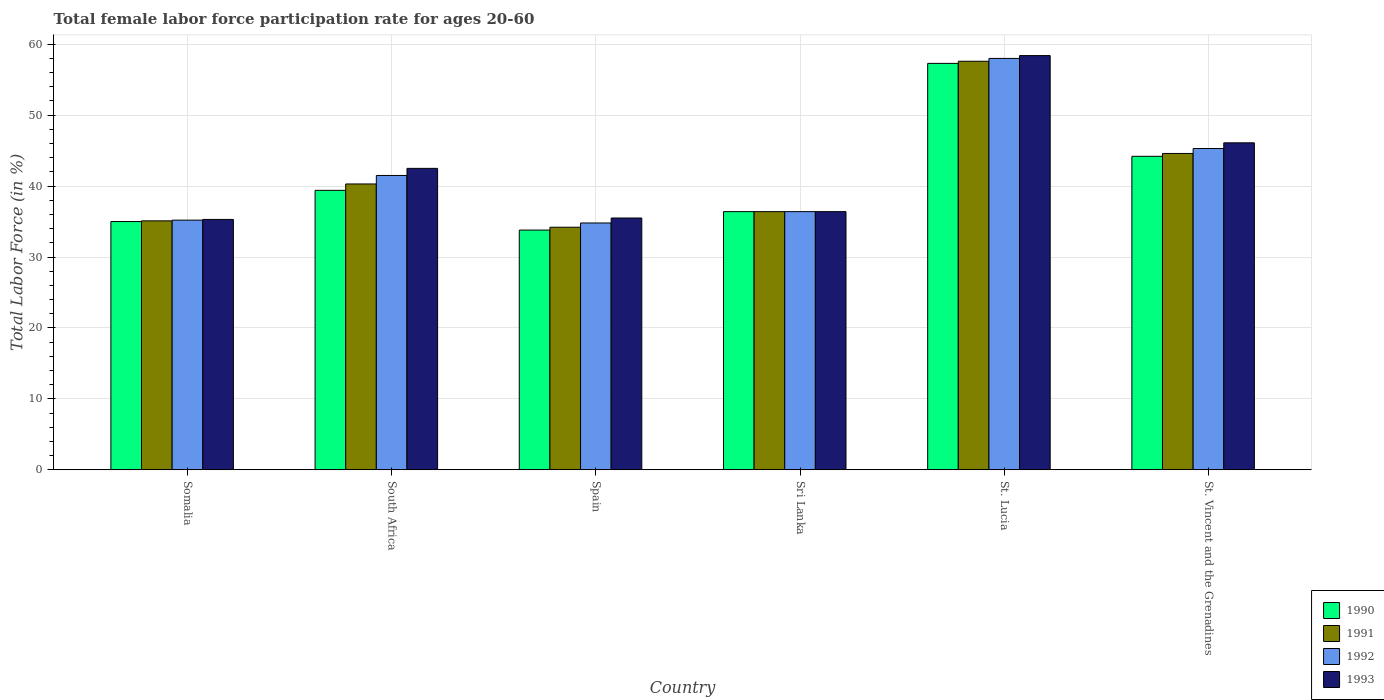How many different coloured bars are there?
Your answer should be very brief. 4. How many bars are there on the 2nd tick from the right?
Your response must be concise. 4. What is the label of the 5th group of bars from the left?
Your answer should be very brief. St. Lucia. What is the female labor force participation rate in 1992 in Somalia?
Offer a terse response. 35.2. Across all countries, what is the maximum female labor force participation rate in 1991?
Your response must be concise. 57.6. Across all countries, what is the minimum female labor force participation rate in 1990?
Your response must be concise. 33.8. In which country was the female labor force participation rate in 1990 maximum?
Your answer should be compact. St. Lucia. What is the total female labor force participation rate in 1993 in the graph?
Your response must be concise. 254.2. What is the difference between the female labor force participation rate in 1990 in South Africa and the female labor force participation rate in 1992 in Spain?
Provide a succinct answer. 4.6. What is the average female labor force participation rate in 1990 per country?
Offer a terse response. 41.02. What is the difference between the female labor force participation rate of/in 1991 and female labor force participation rate of/in 1990 in Somalia?
Make the answer very short. 0.1. In how many countries, is the female labor force participation rate in 1991 greater than 20 %?
Your answer should be very brief. 6. What is the ratio of the female labor force participation rate in 1990 in South Africa to that in St. Lucia?
Give a very brief answer. 0.69. Is the female labor force participation rate in 1990 in South Africa less than that in Spain?
Offer a very short reply. No. What is the difference between the highest and the second highest female labor force participation rate in 1992?
Give a very brief answer. -16.5. What is the difference between the highest and the lowest female labor force participation rate in 1992?
Provide a short and direct response. 23.2. Is it the case that in every country, the sum of the female labor force participation rate in 1993 and female labor force participation rate in 1992 is greater than the sum of female labor force participation rate in 1991 and female labor force participation rate in 1990?
Give a very brief answer. No. What does the 4th bar from the left in South Africa represents?
Offer a terse response. 1993. Is it the case that in every country, the sum of the female labor force participation rate in 1993 and female labor force participation rate in 1992 is greater than the female labor force participation rate in 1991?
Keep it short and to the point. Yes. How many bars are there?
Offer a very short reply. 24. Are all the bars in the graph horizontal?
Offer a terse response. No. Does the graph contain grids?
Your answer should be very brief. Yes. What is the title of the graph?
Provide a succinct answer. Total female labor force participation rate for ages 20-60. Does "1993" appear as one of the legend labels in the graph?
Your answer should be very brief. Yes. What is the label or title of the Y-axis?
Make the answer very short. Total Labor Force (in %). What is the Total Labor Force (in %) in 1991 in Somalia?
Give a very brief answer. 35.1. What is the Total Labor Force (in %) of 1992 in Somalia?
Give a very brief answer. 35.2. What is the Total Labor Force (in %) in 1993 in Somalia?
Ensure brevity in your answer.  35.3. What is the Total Labor Force (in %) of 1990 in South Africa?
Your answer should be compact. 39.4. What is the Total Labor Force (in %) in 1991 in South Africa?
Make the answer very short. 40.3. What is the Total Labor Force (in %) in 1992 in South Africa?
Your answer should be compact. 41.5. What is the Total Labor Force (in %) of 1993 in South Africa?
Give a very brief answer. 42.5. What is the Total Labor Force (in %) of 1990 in Spain?
Provide a succinct answer. 33.8. What is the Total Labor Force (in %) of 1991 in Spain?
Offer a very short reply. 34.2. What is the Total Labor Force (in %) in 1992 in Spain?
Provide a short and direct response. 34.8. What is the Total Labor Force (in %) of 1993 in Spain?
Your answer should be very brief. 35.5. What is the Total Labor Force (in %) of 1990 in Sri Lanka?
Offer a terse response. 36.4. What is the Total Labor Force (in %) in 1991 in Sri Lanka?
Provide a succinct answer. 36.4. What is the Total Labor Force (in %) of 1992 in Sri Lanka?
Offer a very short reply. 36.4. What is the Total Labor Force (in %) in 1993 in Sri Lanka?
Offer a terse response. 36.4. What is the Total Labor Force (in %) of 1990 in St. Lucia?
Provide a short and direct response. 57.3. What is the Total Labor Force (in %) in 1991 in St. Lucia?
Provide a short and direct response. 57.6. What is the Total Labor Force (in %) of 1993 in St. Lucia?
Offer a terse response. 58.4. What is the Total Labor Force (in %) in 1990 in St. Vincent and the Grenadines?
Provide a short and direct response. 44.2. What is the Total Labor Force (in %) of 1991 in St. Vincent and the Grenadines?
Keep it short and to the point. 44.6. What is the Total Labor Force (in %) of 1992 in St. Vincent and the Grenadines?
Offer a very short reply. 45.3. What is the Total Labor Force (in %) of 1993 in St. Vincent and the Grenadines?
Your response must be concise. 46.1. Across all countries, what is the maximum Total Labor Force (in %) of 1990?
Give a very brief answer. 57.3. Across all countries, what is the maximum Total Labor Force (in %) in 1991?
Your answer should be compact. 57.6. Across all countries, what is the maximum Total Labor Force (in %) in 1993?
Provide a succinct answer. 58.4. Across all countries, what is the minimum Total Labor Force (in %) in 1990?
Give a very brief answer. 33.8. Across all countries, what is the minimum Total Labor Force (in %) of 1991?
Your answer should be compact. 34.2. Across all countries, what is the minimum Total Labor Force (in %) of 1992?
Ensure brevity in your answer.  34.8. Across all countries, what is the minimum Total Labor Force (in %) in 1993?
Your response must be concise. 35.3. What is the total Total Labor Force (in %) of 1990 in the graph?
Your answer should be compact. 246.1. What is the total Total Labor Force (in %) of 1991 in the graph?
Offer a very short reply. 248.2. What is the total Total Labor Force (in %) of 1992 in the graph?
Your response must be concise. 251.2. What is the total Total Labor Force (in %) in 1993 in the graph?
Your answer should be very brief. 254.2. What is the difference between the Total Labor Force (in %) of 1990 in Somalia and that in Spain?
Provide a short and direct response. 1.2. What is the difference between the Total Labor Force (in %) of 1990 in Somalia and that in Sri Lanka?
Your answer should be compact. -1.4. What is the difference between the Total Labor Force (in %) of 1990 in Somalia and that in St. Lucia?
Your response must be concise. -22.3. What is the difference between the Total Labor Force (in %) of 1991 in Somalia and that in St. Lucia?
Keep it short and to the point. -22.5. What is the difference between the Total Labor Force (in %) of 1992 in Somalia and that in St. Lucia?
Your answer should be very brief. -22.8. What is the difference between the Total Labor Force (in %) of 1993 in Somalia and that in St. Lucia?
Offer a very short reply. -23.1. What is the difference between the Total Labor Force (in %) of 1991 in Somalia and that in St. Vincent and the Grenadines?
Make the answer very short. -9.5. What is the difference between the Total Labor Force (in %) of 1992 in Somalia and that in St. Vincent and the Grenadines?
Your answer should be compact. -10.1. What is the difference between the Total Labor Force (in %) in 1993 in Somalia and that in St. Vincent and the Grenadines?
Make the answer very short. -10.8. What is the difference between the Total Labor Force (in %) in 1992 in South Africa and that in Spain?
Provide a succinct answer. 6.7. What is the difference between the Total Labor Force (in %) in 1993 in South Africa and that in Spain?
Provide a short and direct response. 7. What is the difference between the Total Labor Force (in %) of 1993 in South Africa and that in Sri Lanka?
Give a very brief answer. 6.1. What is the difference between the Total Labor Force (in %) in 1990 in South Africa and that in St. Lucia?
Provide a succinct answer. -17.9. What is the difference between the Total Labor Force (in %) in 1991 in South Africa and that in St. Lucia?
Ensure brevity in your answer.  -17.3. What is the difference between the Total Labor Force (in %) in 1992 in South Africa and that in St. Lucia?
Provide a short and direct response. -16.5. What is the difference between the Total Labor Force (in %) in 1993 in South Africa and that in St. Lucia?
Your answer should be compact. -15.9. What is the difference between the Total Labor Force (in %) in 1992 in South Africa and that in St. Vincent and the Grenadines?
Offer a terse response. -3.8. What is the difference between the Total Labor Force (in %) in 1993 in South Africa and that in St. Vincent and the Grenadines?
Ensure brevity in your answer.  -3.6. What is the difference between the Total Labor Force (in %) of 1990 in Spain and that in Sri Lanka?
Offer a very short reply. -2.6. What is the difference between the Total Labor Force (in %) of 1991 in Spain and that in Sri Lanka?
Your answer should be very brief. -2.2. What is the difference between the Total Labor Force (in %) of 1990 in Spain and that in St. Lucia?
Provide a succinct answer. -23.5. What is the difference between the Total Labor Force (in %) in 1991 in Spain and that in St. Lucia?
Offer a very short reply. -23.4. What is the difference between the Total Labor Force (in %) of 1992 in Spain and that in St. Lucia?
Provide a short and direct response. -23.2. What is the difference between the Total Labor Force (in %) in 1993 in Spain and that in St. Lucia?
Offer a terse response. -22.9. What is the difference between the Total Labor Force (in %) of 1990 in Spain and that in St. Vincent and the Grenadines?
Your answer should be very brief. -10.4. What is the difference between the Total Labor Force (in %) in 1991 in Spain and that in St. Vincent and the Grenadines?
Provide a short and direct response. -10.4. What is the difference between the Total Labor Force (in %) of 1990 in Sri Lanka and that in St. Lucia?
Your answer should be very brief. -20.9. What is the difference between the Total Labor Force (in %) of 1991 in Sri Lanka and that in St. Lucia?
Offer a very short reply. -21.2. What is the difference between the Total Labor Force (in %) of 1992 in Sri Lanka and that in St. Lucia?
Your response must be concise. -21.6. What is the difference between the Total Labor Force (in %) in 1993 in Sri Lanka and that in St. Lucia?
Ensure brevity in your answer.  -22. What is the difference between the Total Labor Force (in %) in 1990 in Sri Lanka and that in St. Vincent and the Grenadines?
Give a very brief answer. -7.8. What is the difference between the Total Labor Force (in %) of 1992 in Sri Lanka and that in St. Vincent and the Grenadines?
Your response must be concise. -8.9. What is the difference between the Total Labor Force (in %) in 1993 in Sri Lanka and that in St. Vincent and the Grenadines?
Offer a very short reply. -9.7. What is the difference between the Total Labor Force (in %) of 1990 in St. Lucia and that in St. Vincent and the Grenadines?
Offer a very short reply. 13.1. What is the difference between the Total Labor Force (in %) of 1990 in Somalia and the Total Labor Force (in %) of 1992 in South Africa?
Your response must be concise. -6.5. What is the difference between the Total Labor Force (in %) in 1991 in Somalia and the Total Labor Force (in %) in 1992 in South Africa?
Offer a terse response. -6.4. What is the difference between the Total Labor Force (in %) of 1991 in Somalia and the Total Labor Force (in %) of 1993 in South Africa?
Provide a short and direct response. -7.4. What is the difference between the Total Labor Force (in %) in 1990 in Somalia and the Total Labor Force (in %) in 1993 in Spain?
Provide a succinct answer. -0.5. What is the difference between the Total Labor Force (in %) of 1991 in Somalia and the Total Labor Force (in %) of 1992 in Spain?
Provide a succinct answer. 0.3. What is the difference between the Total Labor Force (in %) in 1992 in Somalia and the Total Labor Force (in %) in 1993 in Spain?
Offer a very short reply. -0.3. What is the difference between the Total Labor Force (in %) of 1990 in Somalia and the Total Labor Force (in %) of 1992 in Sri Lanka?
Give a very brief answer. -1.4. What is the difference between the Total Labor Force (in %) in 1990 in Somalia and the Total Labor Force (in %) in 1993 in Sri Lanka?
Your answer should be very brief. -1.4. What is the difference between the Total Labor Force (in %) of 1991 in Somalia and the Total Labor Force (in %) of 1992 in Sri Lanka?
Your answer should be very brief. -1.3. What is the difference between the Total Labor Force (in %) in 1990 in Somalia and the Total Labor Force (in %) in 1991 in St. Lucia?
Offer a terse response. -22.6. What is the difference between the Total Labor Force (in %) in 1990 in Somalia and the Total Labor Force (in %) in 1992 in St. Lucia?
Offer a very short reply. -23. What is the difference between the Total Labor Force (in %) of 1990 in Somalia and the Total Labor Force (in %) of 1993 in St. Lucia?
Offer a terse response. -23.4. What is the difference between the Total Labor Force (in %) of 1991 in Somalia and the Total Labor Force (in %) of 1992 in St. Lucia?
Offer a very short reply. -22.9. What is the difference between the Total Labor Force (in %) in 1991 in Somalia and the Total Labor Force (in %) in 1993 in St. Lucia?
Your answer should be compact. -23.3. What is the difference between the Total Labor Force (in %) in 1992 in Somalia and the Total Labor Force (in %) in 1993 in St. Lucia?
Provide a short and direct response. -23.2. What is the difference between the Total Labor Force (in %) in 1990 in Somalia and the Total Labor Force (in %) in 1992 in St. Vincent and the Grenadines?
Provide a succinct answer. -10.3. What is the difference between the Total Labor Force (in %) of 1991 in Somalia and the Total Labor Force (in %) of 1992 in St. Vincent and the Grenadines?
Your answer should be compact. -10.2. What is the difference between the Total Labor Force (in %) of 1991 in Somalia and the Total Labor Force (in %) of 1993 in St. Vincent and the Grenadines?
Ensure brevity in your answer.  -11. What is the difference between the Total Labor Force (in %) of 1992 in Somalia and the Total Labor Force (in %) of 1993 in St. Vincent and the Grenadines?
Provide a short and direct response. -10.9. What is the difference between the Total Labor Force (in %) in 1990 in South Africa and the Total Labor Force (in %) in 1992 in Spain?
Your answer should be very brief. 4.6. What is the difference between the Total Labor Force (in %) in 1991 in South Africa and the Total Labor Force (in %) in 1992 in Spain?
Your response must be concise. 5.5. What is the difference between the Total Labor Force (in %) of 1990 in South Africa and the Total Labor Force (in %) of 1992 in Sri Lanka?
Your response must be concise. 3. What is the difference between the Total Labor Force (in %) of 1991 in South Africa and the Total Labor Force (in %) of 1993 in Sri Lanka?
Ensure brevity in your answer.  3.9. What is the difference between the Total Labor Force (in %) in 1990 in South Africa and the Total Labor Force (in %) in 1991 in St. Lucia?
Your response must be concise. -18.2. What is the difference between the Total Labor Force (in %) of 1990 in South Africa and the Total Labor Force (in %) of 1992 in St. Lucia?
Make the answer very short. -18.6. What is the difference between the Total Labor Force (in %) in 1990 in South Africa and the Total Labor Force (in %) in 1993 in St. Lucia?
Make the answer very short. -19. What is the difference between the Total Labor Force (in %) in 1991 in South Africa and the Total Labor Force (in %) in 1992 in St. Lucia?
Ensure brevity in your answer.  -17.7. What is the difference between the Total Labor Force (in %) of 1991 in South Africa and the Total Labor Force (in %) of 1993 in St. Lucia?
Make the answer very short. -18.1. What is the difference between the Total Labor Force (in %) in 1992 in South Africa and the Total Labor Force (in %) in 1993 in St. Lucia?
Provide a succinct answer. -16.9. What is the difference between the Total Labor Force (in %) of 1991 in South Africa and the Total Labor Force (in %) of 1992 in St. Vincent and the Grenadines?
Ensure brevity in your answer.  -5. What is the difference between the Total Labor Force (in %) of 1992 in South Africa and the Total Labor Force (in %) of 1993 in St. Vincent and the Grenadines?
Provide a succinct answer. -4.6. What is the difference between the Total Labor Force (in %) in 1990 in Spain and the Total Labor Force (in %) in 1992 in Sri Lanka?
Provide a short and direct response. -2.6. What is the difference between the Total Labor Force (in %) in 1991 in Spain and the Total Labor Force (in %) in 1992 in Sri Lanka?
Offer a very short reply. -2.2. What is the difference between the Total Labor Force (in %) of 1992 in Spain and the Total Labor Force (in %) of 1993 in Sri Lanka?
Give a very brief answer. -1.6. What is the difference between the Total Labor Force (in %) of 1990 in Spain and the Total Labor Force (in %) of 1991 in St. Lucia?
Your response must be concise. -23.8. What is the difference between the Total Labor Force (in %) of 1990 in Spain and the Total Labor Force (in %) of 1992 in St. Lucia?
Keep it short and to the point. -24.2. What is the difference between the Total Labor Force (in %) in 1990 in Spain and the Total Labor Force (in %) in 1993 in St. Lucia?
Ensure brevity in your answer.  -24.6. What is the difference between the Total Labor Force (in %) of 1991 in Spain and the Total Labor Force (in %) of 1992 in St. Lucia?
Your answer should be very brief. -23.8. What is the difference between the Total Labor Force (in %) of 1991 in Spain and the Total Labor Force (in %) of 1993 in St. Lucia?
Give a very brief answer. -24.2. What is the difference between the Total Labor Force (in %) of 1992 in Spain and the Total Labor Force (in %) of 1993 in St. Lucia?
Your answer should be very brief. -23.6. What is the difference between the Total Labor Force (in %) in 1990 in Spain and the Total Labor Force (in %) in 1991 in St. Vincent and the Grenadines?
Your answer should be compact. -10.8. What is the difference between the Total Labor Force (in %) in 1991 in Spain and the Total Labor Force (in %) in 1992 in St. Vincent and the Grenadines?
Give a very brief answer. -11.1. What is the difference between the Total Labor Force (in %) of 1991 in Spain and the Total Labor Force (in %) of 1993 in St. Vincent and the Grenadines?
Give a very brief answer. -11.9. What is the difference between the Total Labor Force (in %) of 1992 in Spain and the Total Labor Force (in %) of 1993 in St. Vincent and the Grenadines?
Offer a very short reply. -11.3. What is the difference between the Total Labor Force (in %) of 1990 in Sri Lanka and the Total Labor Force (in %) of 1991 in St. Lucia?
Offer a very short reply. -21.2. What is the difference between the Total Labor Force (in %) in 1990 in Sri Lanka and the Total Labor Force (in %) in 1992 in St. Lucia?
Make the answer very short. -21.6. What is the difference between the Total Labor Force (in %) of 1990 in Sri Lanka and the Total Labor Force (in %) of 1993 in St. Lucia?
Offer a very short reply. -22. What is the difference between the Total Labor Force (in %) in 1991 in Sri Lanka and the Total Labor Force (in %) in 1992 in St. Lucia?
Make the answer very short. -21.6. What is the difference between the Total Labor Force (in %) of 1991 in Sri Lanka and the Total Labor Force (in %) of 1993 in St. Lucia?
Provide a succinct answer. -22. What is the difference between the Total Labor Force (in %) of 1992 in Sri Lanka and the Total Labor Force (in %) of 1993 in St. Lucia?
Your response must be concise. -22. What is the difference between the Total Labor Force (in %) in 1990 in Sri Lanka and the Total Labor Force (in %) in 1991 in St. Vincent and the Grenadines?
Your answer should be compact. -8.2. What is the difference between the Total Labor Force (in %) of 1990 in Sri Lanka and the Total Labor Force (in %) of 1992 in St. Vincent and the Grenadines?
Offer a very short reply. -8.9. What is the difference between the Total Labor Force (in %) in 1990 in Sri Lanka and the Total Labor Force (in %) in 1993 in St. Vincent and the Grenadines?
Make the answer very short. -9.7. What is the difference between the Total Labor Force (in %) in 1991 in Sri Lanka and the Total Labor Force (in %) in 1992 in St. Vincent and the Grenadines?
Make the answer very short. -8.9. What is the difference between the Total Labor Force (in %) in 1990 in St. Lucia and the Total Labor Force (in %) in 1991 in St. Vincent and the Grenadines?
Keep it short and to the point. 12.7. What is the difference between the Total Labor Force (in %) of 1990 in St. Lucia and the Total Labor Force (in %) of 1992 in St. Vincent and the Grenadines?
Ensure brevity in your answer.  12. What is the difference between the Total Labor Force (in %) of 1990 in St. Lucia and the Total Labor Force (in %) of 1993 in St. Vincent and the Grenadines?
Make the answer very short. 11.2. What is the difference between the Total Labor Force (in %) in 1991 in St. Lucia and the Total Labor Force (in %) in 1992 in St. Vincent and the Grenadines?
Offer a terse response. 12.3. What is the difference between the Total Labor Force (in %) of 1992 in St. Lucia and the Total Labor Force (in %) of 1993 in St. Vincent and the Grenadines?
Give a very brief answer. 11.9. What is the average Total Labor Force (in %) in 1990 per country?
Your response must be concise. 41.02. What is the average Total Labor Force (in %) in 1991 per country?
Provide a short and direct response. 41.37. What is the average Total Labor Force (in %) in 1992 per country?
Your answer should be compact. 41.87. What is the average Total Labor Force (in %) of 1993 per country?
Make the answer very short. 42.37. What is the difference between the Total Labor Force (in %) of 1990 and Total Labor Force (in %) of 1991 in Somalia?
Offer a very short reply. -0.1. What is the difference between the Total Labor Force (in %) in 1991 and Total Labor Force (in %) in 1992 in Somalia?
Give a very brief answer. -0.1. What is the difference between the Total Labor Force (in %) in 1991 and Total Labor Force (in %) in 1993 in Somalia?
Offer a very short reply. -0.2. What is the difference between the Total Labor Force (in %) of 1992 and Total Labor Force (in %) of 1993 in Somalia?
Ensure brevity in your answer.  -0.1. What is the difference between the Total Labor Force (in %) of 1990 and Total Labor Force (in %) of 1992 in South Africa?
Give a very brief answer. -2.1. What is the difference between the Total Labor Force (in %) in 1990 and Total Labor Force (in %) in 1993 in South Africa?
Offer a terse response. -3.1. What is the difference between the Total Labor Force (in %) of 1991 and Total Labor Force (in %) of 1993 in South Africa?
Offer a terse response. -2.2. What is the difference between the Total Labor Force (in %) in 1992 and Total Labor Force (in %) in 1993 in South Africa?
Make the answer very short. -1. What is the difference between the Total Labor Force (in %) of 1992 and Total Labor Force (in %) of 1993 in Spain?
Your answer should be compact. -0.7. What is the difference between the Total Labor Force (in %) of 1990 and Total Labor Force (in %) of 1991 in Sri Lanka?
Provide a short and direct response. 0. What is the difference between the Total Labor Force (in %) in 1991 and Total Labor Force (in %) in 1992 in Sri Lanka?
Make the answer very short. 0. What is the difference between the Total Labor Force (in %) of 1990 and Total Labor Force (in %) of 1992 in St. Lucia?
Make the answer very short. -0.7. What is the difference between the Total Labor Force (in %) of 1990 and Total Labor Force (in %) of 1993 in St. Lucia?
Your answer should be compact. -1.1. What is the difference between the Total Labor Force (in %) in 1991 and Total Labor Force (in %) in 1992 in St. Lucia?
Offer a very short reply. -0.4. What is the difference between the Total Labor Force (in %) of 1992 and Total Labor Force (in %) of 1993 in St. Lucia?
Your answer should be very brief. -0.4. What is the difference between the Total Labor Force (in %) of 1990 and Total Labor Force (in %) of 1991 in St. Vincent and the Grenadines?
Keep it short and to the point. -0.4. What is the difference between the Total Labor Force (in %) in 1991 and Total Labor Force (in %) in 1993 in St. Vincent and the Grenadines?
Offer a very short reply. -1.5. What is the difference between the Total Labor Force (in %) of 1992 and Total Labor Force (in %) of 1993 in St. Vincent and the Grenadines?
Make the answer very short. -0.8. What is the ratio of the Total Labor Force (in %) of 1990 in Somalia to that in South Africa?
Give a very brief answer. 0.89. What is the ratio of the Total Labor Force (in %) in 1991 in Somalia to that in South Africa?
Provide a short and direct response. 0.87. What is the ratio of the Total Labor Force (in %) of 1992 in Somalia to that in South Africa?
Your answer should be very brief. 0.85. What is the ratio of the Total Labor Force (in %) in 1993 in Somalia to that in South Africa?
Offer a terse response. 0.83. What is the ratio of the Total Labor Force (in %) in 1990 in Somalia to that in Spain?
Keep it short and to the point. 1.04. What is the ratio of the Total Labor Force (in %) in 1991 in Somalia to that in Spain?
Keep it short and to the point. 1.03. What is the ratio of the Total Labor Force (in %) in 1992 in Somalia to that in Spain?
Provide a succinct answer. 1.01. What is the ratio of the Total Labor Force (in %) of 1993 in Somalia to that in Spain?
Your answer should be compact. 0.99. What is the ratio of the Total Labor Force (in %) of 1990 in Somalia to that in Sri Lanka?
Make the answer very short. 0.96. What is the ratio of the Total Labor Force (in %) in 1992 in Somalia to that in Sri Lanka?
Offer a very short reply. 0.97. What is the ratio of the Total Labor Force (in %) in 1993 in Somalia to that in Sri Lanka?
Your answer should be very brief. 0.97. What is the ratio of the Total Labor Force (in %) in 1990 in Somalia to that in St. Lucia?
Make the answer very short. 0.61. What is the ratio of the Total Labor Force (in %) in 1991 in Somalia to that in St. Lucia?
Your answer should be compact. 0.61. What is the ratio of the Total Labor Force (in %) in 1992 in Somalia to that in St. Lucia?
Ensure brevity in your answer.  0.61. What is the ratio of the Total Labor Force (in %) in 1993 in Somalia to that in St. Lucia?
Make the answer very short. 0.6. What is the ratio of the Total Labor Force (in %) of 1990 in Somalia to that in St. Vincent and the Grenadines?
Your answer should be very brief. 0.79. What is the ratio of the Total Labor Force (in %) of 1991 in Somalia to that in St. Vincent and the Grenadines?
Keep it short and to the point. 0.79. What is the ratio of the Total Labor Force (in %) of 1992 in Somalia to that in St. Vincent and the Grenadines?
Provide a succinct answer. 0.78. What is the ratio of the Total Labor Force (in %) in 1993 in Somalia to that in St. Vincent and the Grenadines?
Provide a succinct answer. 0.77. What is the ratio of the Total Labor Force (in %) of 1990 in South Africa to that in Spain?
Offer a very short reply. 1.17. What is the ratio of the Total Labor Force (in %) of 1991 in South Africa to that in Spain?
Offer a very short reply. 1.18. What is the ratio of the Total Labor Force (in %) of 1992 in South Africa to that in Spain?
Give a very brief answer. 1.19. What is the ratio of the Total Labor Force (in %) in 1993 in South Africa to that in Spain?
Your answer should be compact. 1.2. What is the ratio of the Total Labor Force (in %) in 1990 in South Africa to that in Sri Lanka?
Make the answer very short. 1.08. What is the ratio of the Total Labor Force (in %) in 1991 in South Africa to that in Sri Lanka?
Provide a short and direct response. 1.11. What is the ratio of the Total Labor Force (in %) of 1992 in South Africa to that in Sri Lanka?
Ensure brevity in your answer.  1.14. What is the ratio of the Total Labor Force (in %) of 1993 in South Africa to that in Sri Lanka?
Give a very brief answer. 1.17. What is the ratio of the Total Labor Force (in %) of 1990 in South Africa to that in St. Lucia?
Offer a terse response. 0.69. What is the ratio of the Total Labor Force (in %) in 1991 in South Africa to that in St. Lucia?
Provide a short and direct response. 0.7. What is the ratio of the Total Labor Force (in %) of 1992 in South Africa to that in St. Lucia?
Offer a terse response. 0.72. What is the ratio of the Total Labor Force (in %) of 1993 in South Africa to that in St. Lucia?
Make the answer very short. 0.73. What is the ratio of the Total Labor Force (in %) in 1990 in South Africa to that in St. Vincent and the Grenadines?
Offer a terse response. 0.89. What is the ratio of the Total Labor Force (in %) in 1991 in South Africa to that in St. Vincent and the Grenadines?
Your answer should be compact. 0.9. What is the ratio of the Total Labor Force (in %) in 1992 in South Africa to that in St. Vincent and the Grenadines?
Provide a succinct answer. 0.92. What is the ratio of the Total Labor Force (in %) of 1993 in South Africa to that in St. Vincent and the Grenadines?
Provide a short and direct response. 0.92. What is the ratio of the Total Labor Force (in %) in 1991 in Spain to that in Sri Lanka?
Your answer should be very brief. 0.94. What is the ratio of the Total Labor Force (in %) of 1992 in Spain to that in Sri Lanka?
Offer a very short reply. 0.96. What is the ratio of the Total Labor Force (in %) of 1993 in Spain to that in Sri Lanka?
Offer a terse response. 0.98. What is the ratio of the Total Labor Force (in %) of 1990 in Spain to that in St. Lucia?
Your answer should be compact. 0.59. What is the ratio of the Total Labor Force (in %) of 1991 in Spain to that in St. Lucia?
Provide a short and direct response. 0.59. What is the ratio of the Total Labor Force (in %) of 1993 in Spain to that in St. Lucia?
Your answer should be compact. 0.61. What is the ratio of the Total Labor Force (in %) of 1990 in Spain to that in St. Vincent and the Grenadines?
Ensure brevity in your answer.  0.76. What is the ratio of the Total Labor Force (in %) in 1991 in Spain to that in St. Vincent and the Grenadines?
Your response must be concise. 0.77. What is the ratio of the Total Labor Force (in %) in 1992 in Spain to that in St. Vincent and the Grenadines?
Provide a succinct answer. 0.77. What is the ratio of the Total Labor Force (in %) in 1993 in Spain to that in St. Vincent and the Grenadines?
Offer a very short reply. 0.77. What is the ratio of the Total Labor Force (in %) of 1990 in Sri Lanka to that in St. Lucia?
Keep it short and to the point. 0.64. What is the ratio of the Total Labor Force (in %) of 1991 in Sri Lanka to that in St. Lucia?
Make the answer very short. 0.63. What is the ratio of the Total Labor Force (in %) of 1992 in Sri Lanka to that in St. Lucia?
Your answer should be very brief. 0.63. What is the ratio of the Total Labor Force (in %) of 1993 in Sri Lanka to that in St. Lucia?
Provide a short and direct response. 0.62. What is the ratio of the Total Labor Force (in %) in 1990 in Sri Lanka to that in St. Vincent and the Grenadines?
Your answer should be very brief. 0.82. What is the ratio of the Total Labor Force (in %) in 1991 in Sri Lanka to that in St. Vincent and the Grenadines?
Offer a very short reply. 0.82. What is the ratio of the Total Labor Force (in %) in 1992 in Sri Lanka to that in St. Vincent and the Grenadines?
Your response must be concise. 0.8. What is the ratio of the Total Labor Force (in %) in 1993 in Sri Lanka to that in St. Vincent and the Grenadines?
Provide a succinct answer. 0.79. What is the ratio of the Total Labor Force (in %) in 1990 in St. Lucia to that in St. Vincent and the Grenadines?
Your response must be concise. 1.3. What is the ratio of the Total Labor Force (in %) in 1991 in St. Lucia to that in St. Vincent and the Grenadines?
Keep it short and to the point. 1.29. What is the ratio of the Total Labor Force (in %) in 1992 in St. Lucia to that in St. Vincent and the Grenadines?
Make the answer very short. 1.28. What is the ratio of the Total Labor Force (in %) in 1993 in St. Lucia to that in St. Vincent and the Grenadines?
Provide a short and direct response. 1.27. What is the difference between the highest and the second highest Total Labor Force (in %) of 1990?
Make the answer very short. 13.1. What is the difference between the highest and the second highest Total Labor Force (in %) in 1992?
Your answer should be very brief. 12.7. What is the difference between the highest and the second highest Total Labor Force (in %) of 1993?
Your answer should be very brief. 12.3. What is the difference between the highest and the lowest Total Labor Force (in %) of 1990?
Make the answer very short. 23.5. What is the difference between the highest and the lowest Total Labor Force (in %) of 1991?
Offer a terse response. 23.4. What is the difference between the highest and the lowest Total Labor Force (in %) of 1992?
Offer a terse response. 23.2. What is the difference between the highest and the lowest Total Labor Force (in %) of 1993?
Provide a short and direct response. 23.1. 